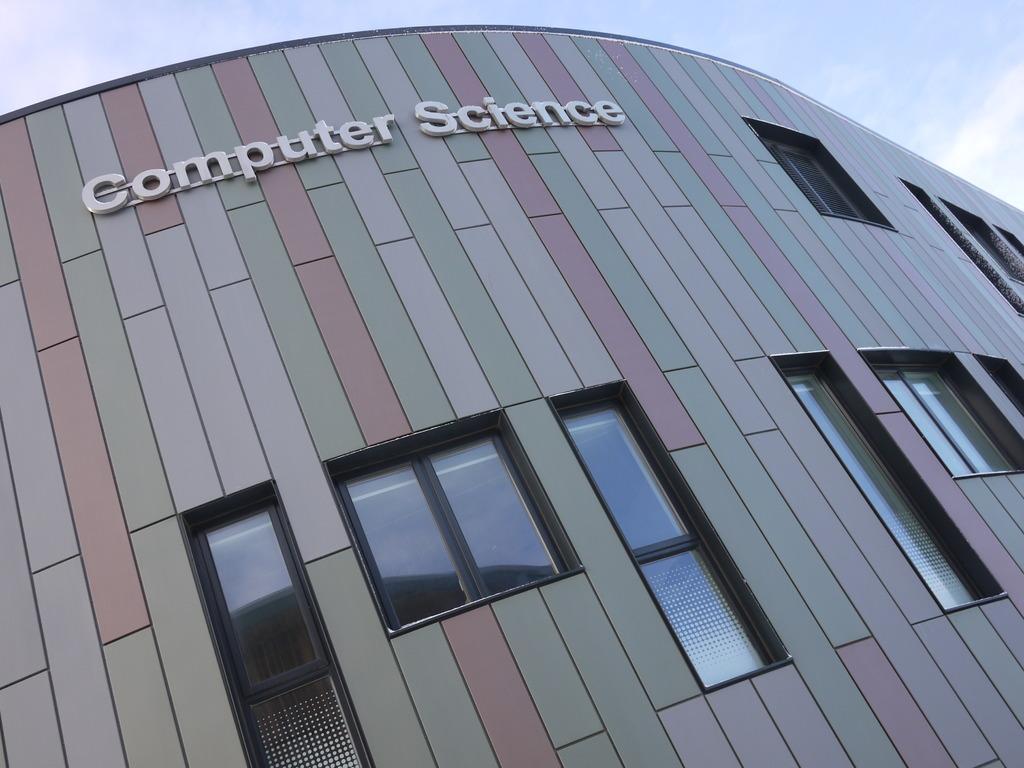Could you give a brief overview of what you see in this image? In this image we can see a building with group of windows and some text on it. In the background , we can see the cloudy sky. 